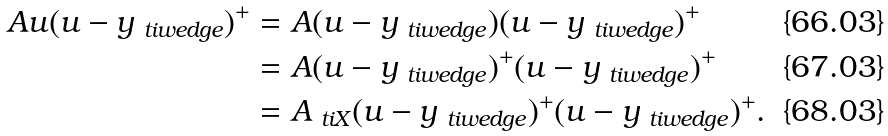Convert formula to latex. <formula><loc_0><loc_0><loc_500><loc_500>A u ( u - y _ { \ t i w e d g e } ) ^ { + } & = A ( u - y _ { \ t i w e d g e } ) ( u - y _ { \ t i w e d g e } ) ^ { + } \\ & = A ( u - y _ { \ t i w e d g e } ) ^ { + } ( u - y _ { \ t i w e d g e } ) ^ { + } \\ & = A _ { \ t i X } ( u - y _ { \ t i w e d g e } ) ^ { + } ( u - y _ { \ t i w e d g e } ) ^ { + } .</formula> 